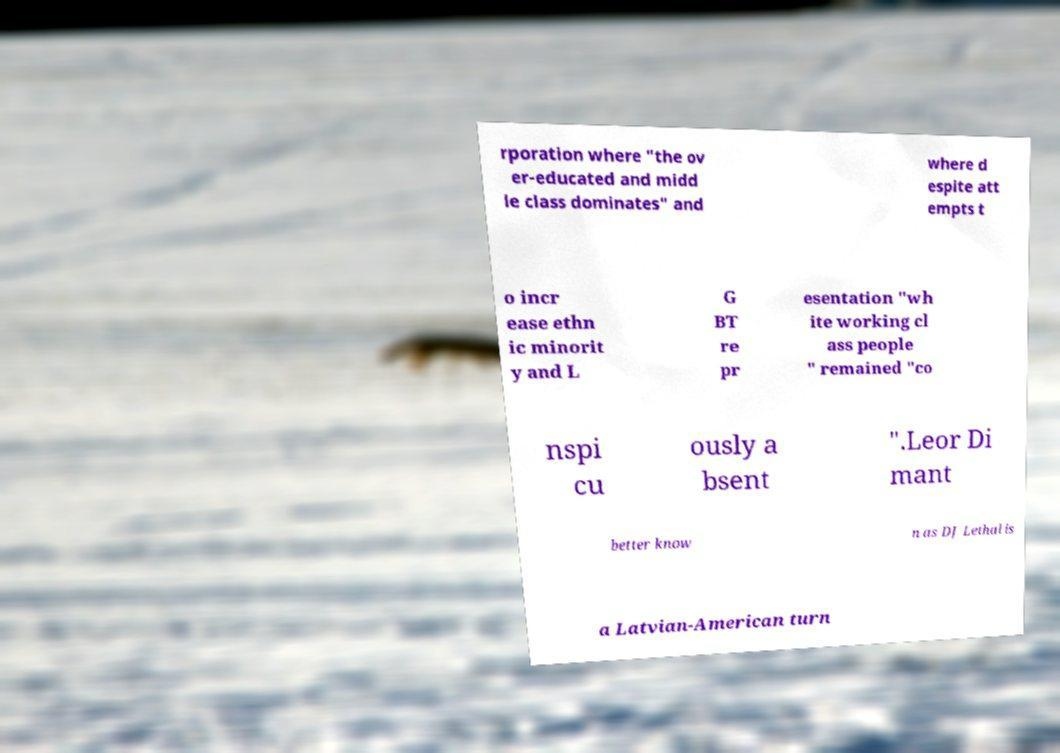Please identify and transcribe the text found in this image. rporation where "the ov er-educated and midd le class dominates" and where d espite att empts t o incr ease ethn ic minorit y and L G BT re pr esentation "wh ite working cl ass people " remained "co nspi cu ously a bsent ".Leor Di mant better know n as DJ Lethal is a Latvian-American turn 